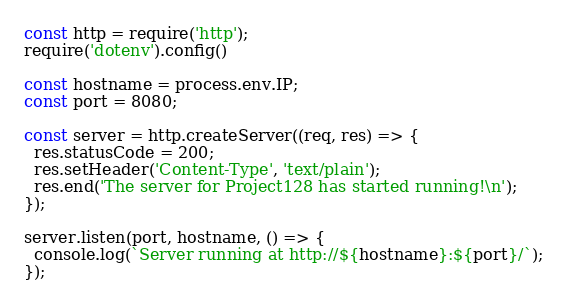<code> <loc_0><loc_0><loc_500><loc_500><_JavaScript_>const http = require('http');
require('dotenv').config()

const hostname = process.env.IP;
const port = 8080;

const server = http.createServer((req, res) => {
  res.statusCode = 200;
  res.setHeader('Content-Type', 'text/plain');
  res.end('The server for Project128 has started running!\n');
});

server.listen(port, hostname, () => {
  console.log(`Server running at http://${hostname}:${port}/`);
});</code> 